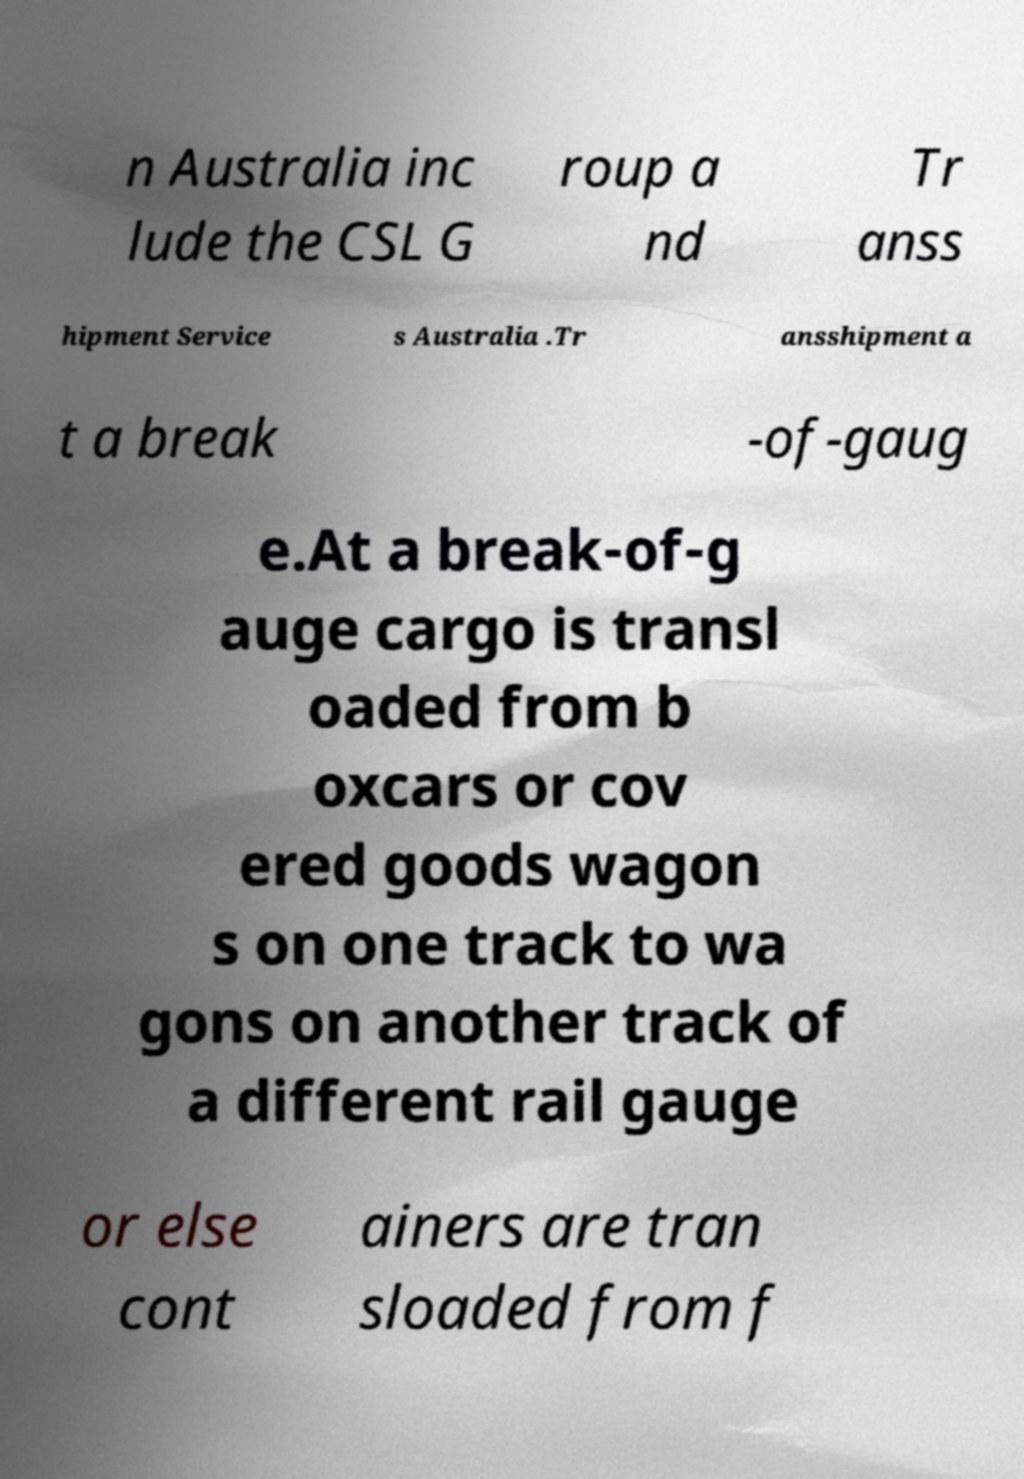Could you extract and type out the text from this image? n Australia inc lude the CSL G roup a nd Tr anss hipment Service s Australia .Tr ansshipment a t a break -of-gaug e.At a break-of-g auge cargo is transl oaded from b oxcars or cov ered goods wagon s on one track to wa gons on another track of a different rail gauge or else cont ainers are tran sloaded from f 